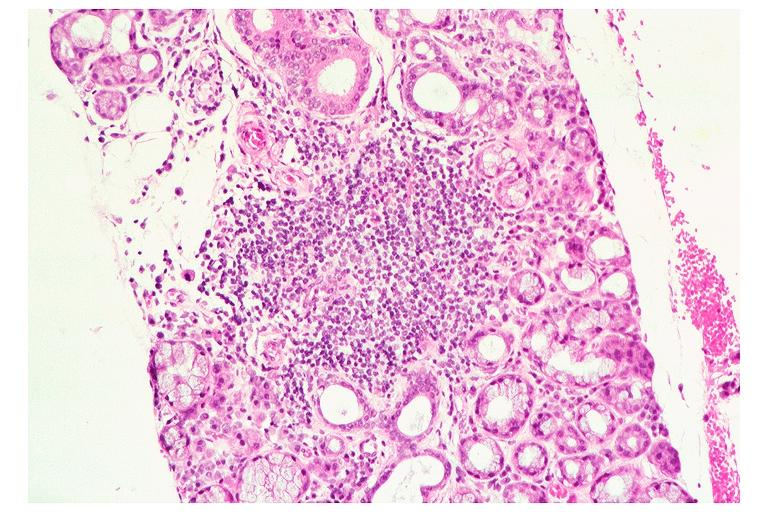does bone, clivus show sjogrens syndrome?
Answer the question using a single word or phrase. No 